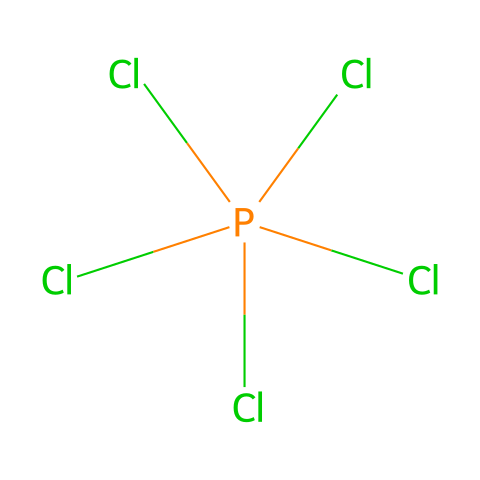What is the molecular formula of phosphorus pentachloride? The SMILES representation indicates the presence of one phosphorus (P) atom and five chlorine (Cl) atoms, which together form the molecular structure. Therefore, the molecular formula derived from the structure is PCl5.
Answer: PCl5 How many chlorine atoms are attached to the phosphorus atom in the structure? By analyzing the SMILES notation, we observe that phosphorus is bonded to five chlorine atoms, as denoted by the "(Cl)" four times and the initial "Cl" in the representation.
Answer: 5 Is phosphorus pentachloride a hypervalent compound? Phosphorus pentachloride has a phosphorus atom that forms five bonds, exceeding the typical four bond limit of many elements, which defines it as hypervalent.
Answer: Yes What type of chemical bond primarily exists between phosphorus and chlorine in this compound? The connections between phosphorus and chlorine in phosphorus pentachloride are covalent bonds in which the phosphorus atom shares electrons with chlorine atoms.
Answer: Covalent What is the hybridization of the phosphorus atom in phosphorus pentachloride? In phosphorus pentachloride, the phosphorus atom is surrounded by five bonding pairs of electrons. This arrangement corresponds to sp3d hybridization, indicating that it uses one s, three p, and one d orbital.
Answer: sp3d What is a primary use of phosphorus pentachloride in industry? Phosphorus pentachloride is commonly utilized in organic synthesis, particularly as a reagent for chlorinating other organic compounds, thus facilitating chemical transformations in the industry.
Answer: Chlorination 